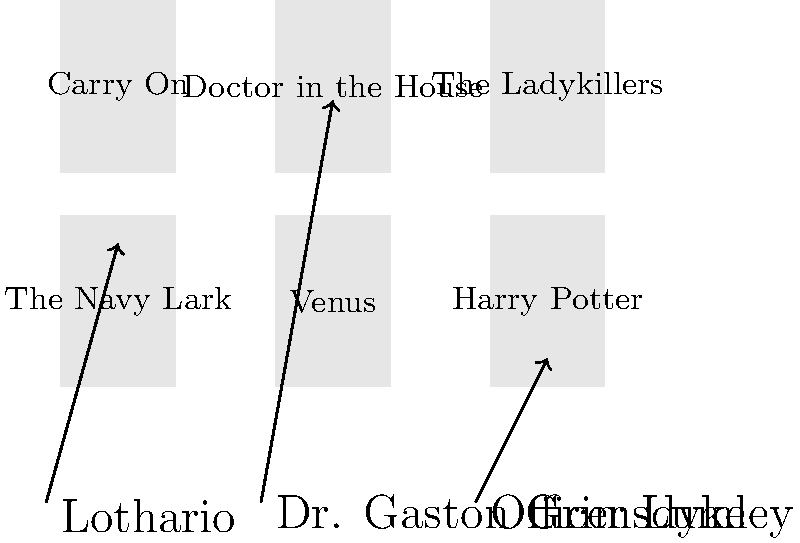Match Leslie Phillips's iconic roles to the correct movie posters by drawing lines between them. Which role-movie pairing is incorrect? Let's examine each pairing:

1. "Lothario" is connected to "The Navy Lark": This is correct. Leslie Phillips played a character often referred to as a "Lothario" (a man who seduces women) in the radio series "The Navy Lark," which was later adapted for film.

2. "Dr. Gaston Grimsdyke" is connected to "Doctor in the House": This is correct. Leslie Phillips portrayed the character of Dr. Gaston Grimsdyke in the "Doctor" series of films, including "Doctor in the House."

3. "Officer Lumley" is connected to "Harry Potter": This is incorrect. Leslie Phillips did appear in the Harry Potter film series, but not as Officer Lumley. He voiced the Sorting Hat in several of the films.

Officer Lumley was actually a character Leslie Phillips played in the "Carry On" film series, specifically in "Carry On Teacher" and "Carry On Constable."

Therefore, the incorrect pairing is "Officer Lumley" with "Harry Potter."
Answer: Officer Lumley - Harry Potter 